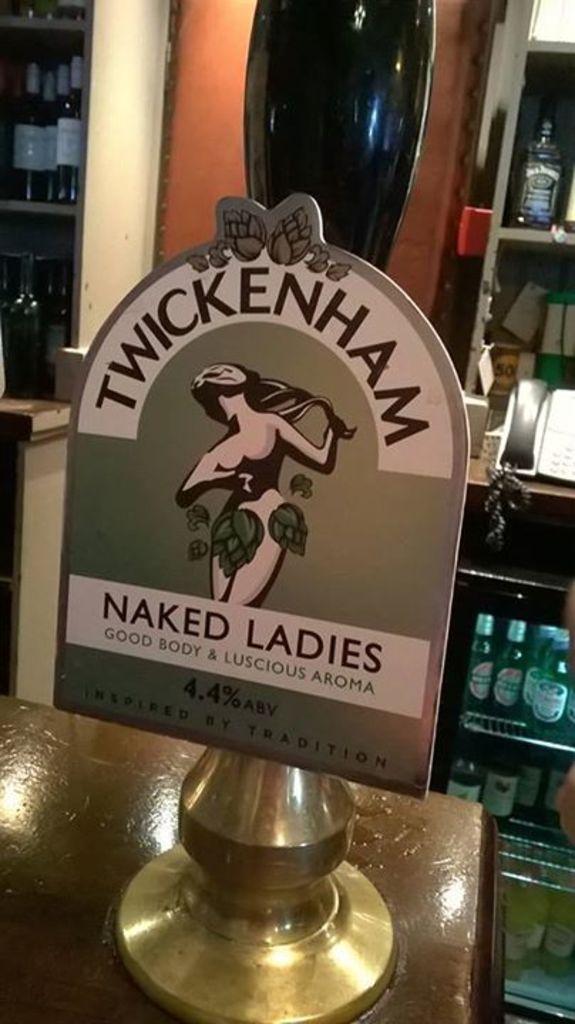What percent alcohol is this?
Your answer should be compact. 4.4%. Who does the sign say are naked?
Offer a very short reply. Ladies. 